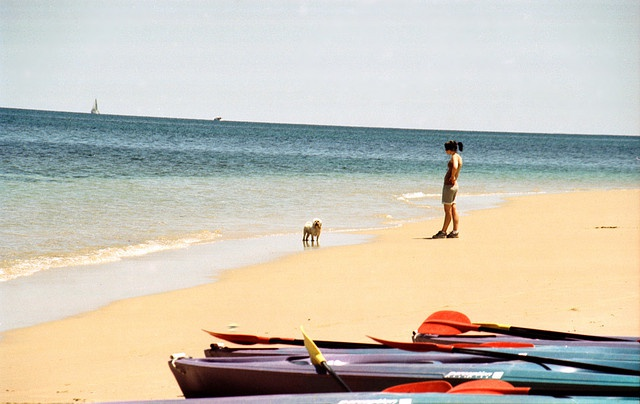Describe the objects in this image and their specific colors. I can see boat in lightgray, black, darkgray, teal, and gray tones, boat in lightgray, black, darkgray, red, and tan tones, people in lightgray, maroon, black, and brown tones, dog in lightgray, ivory, olive, and maroon tones, and boat in lightgray, darkgray, and gray tones in this image. 